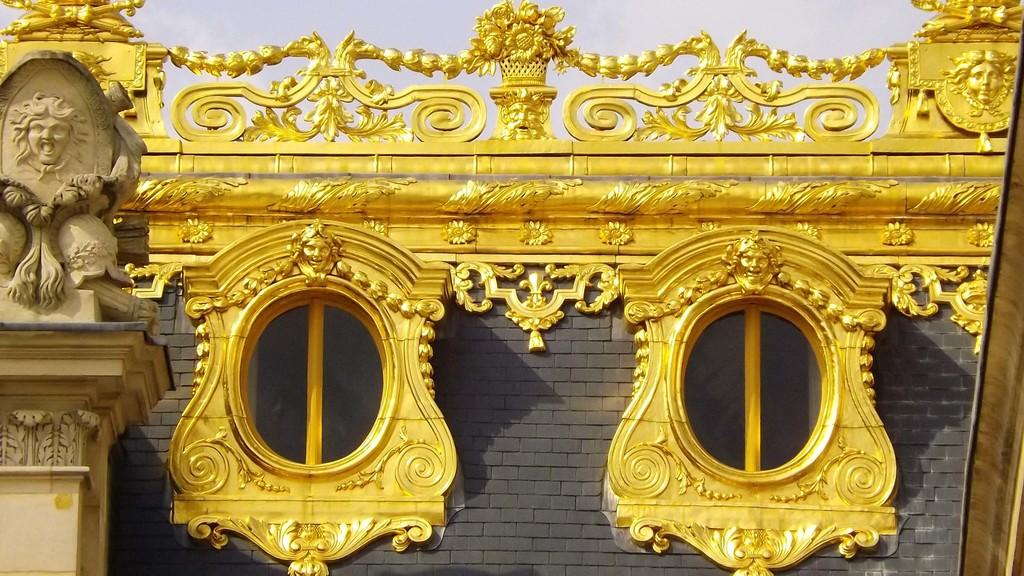What type of structure is visible in the image? There is a brick wall in the image. What feature can be seen on the brick wall? The brick wall has golden framed windows. What other element is present on the brick wall? The brick wall has railing on it. What can be seen on the left side of the image? There is a brown pillar on the left side of the image. What word is written on the railing of the brick wall in the image? There is no word written on the railing of the brick wall in the image. How many seats are visible in the image? There are no seats visible in the image; it only features a brick wall, golden framed windows, railing, and a brown pillar. 